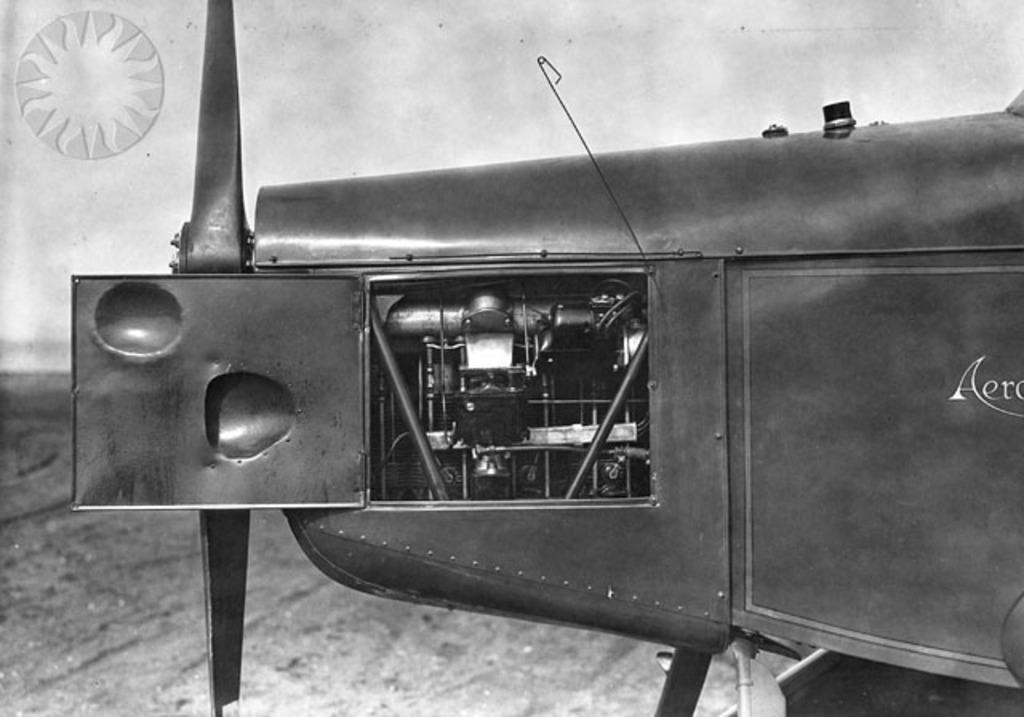What is the main object in the foreground of the image? There is a black color object in the foreground of the image. What can be seen on the black color object? The black color object has text on it. What can be seen in the background of the image? The ground is visible in the background of the image. Is there any other color object in the background? Yes, there is a white color object in the background of the image. What type of boundary can be seen between the black and white color objects in the image? There is no boundary between the black and white color objects in the image; they are simply located in different areas of the image. What title is given to the black color object in the image? There is no title provided for the black color object in the image; it only has text on it. 